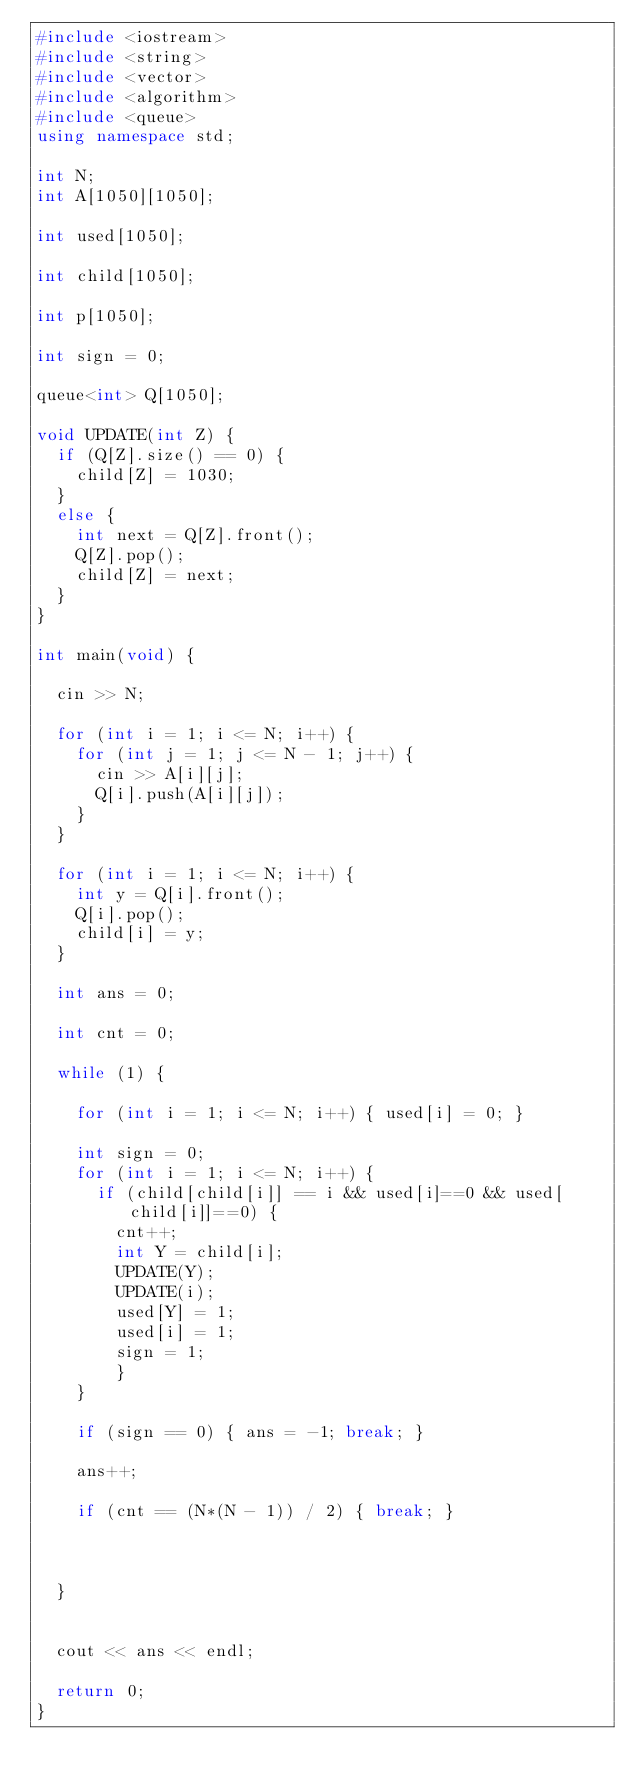Convert code to text. <code><loc_0><loc_0><loc_500><loc_500><_C++_>#include <iostream>
#include <string>
#include <vector>
#include <algorithm>
#include <queue>
using namespace std;

int N;
int A[1050][1050];

int used[1050];

int child[1050];

int p[1050];

int sign = 0;

queue<int> Q[1050];

void UPDATE(int Z) {
	if (Q[Z].size() == 0) {
		child[Z] = 1030;
	}
	else {
		int next = Q[Z].front();
		Q[Z].pop();
		child[Z] = next;
	}
}

int main(void) {

	cin >> N;

	for (int i = 1; i <= N; i++) {
		for (int j = 1; j <= N - 1; j++) {
			cin >> A[i][j];
			Q[i].push(A[i][j]);
		}
	}

	for (int i = 1; i <= N; i++) {
		int y = Q[i].front();
		Q[i].pop();
		child[i] = y;
	}

	int ans = 0;

	int cnt = 0;

	while (1) {

		for (int i = 1; i <= N; i++) { used[i] = 0; }

		int sign = 0;
		for (int i = 1; i <= N; i++) {
			if (child[child[i]] == i && used[i]==0 && used[child[i]]==0) { 
				cnt++;
				int Y = child[i];
				UPDATE(Y);
				UPDATE(i);
				used[Y] = 1;
				used[i] = 1;
				sign = 1;
				}
		}

		if (sign == 0) { ans = -1; break; }

		ans++;

		if (cnt == (N*(N - 1)) / 2) { break; }

		

	}


	cout << ans << endl;

	return 0;
}</code> 